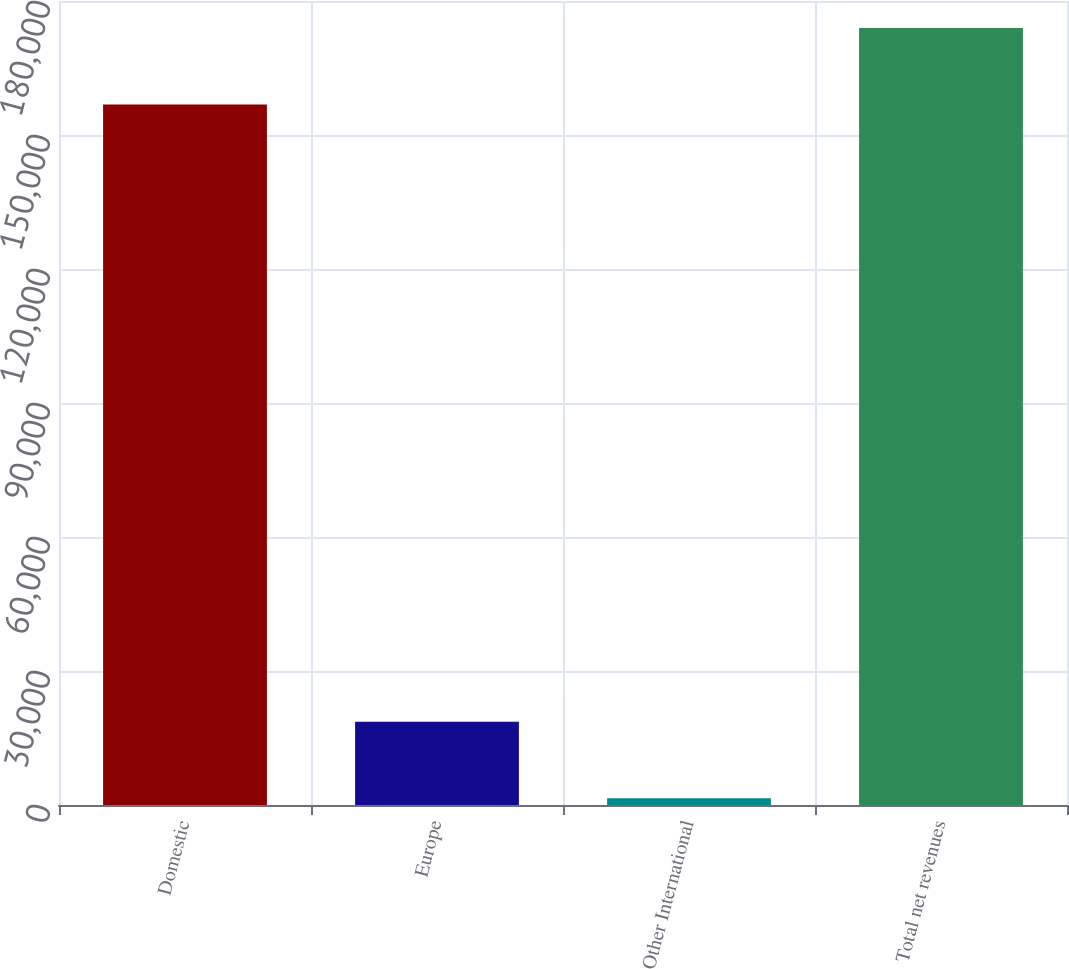<chart> <loc_0><loc_0><loc_500><loc_500><bar_chart><fcel>Domestic<fcel>Europe<fcel>Other International<fcel>Total net revenues<nl><fcel>156837<fcel>18624.9<fcel>1491<fcel>173971<nl></chart> 